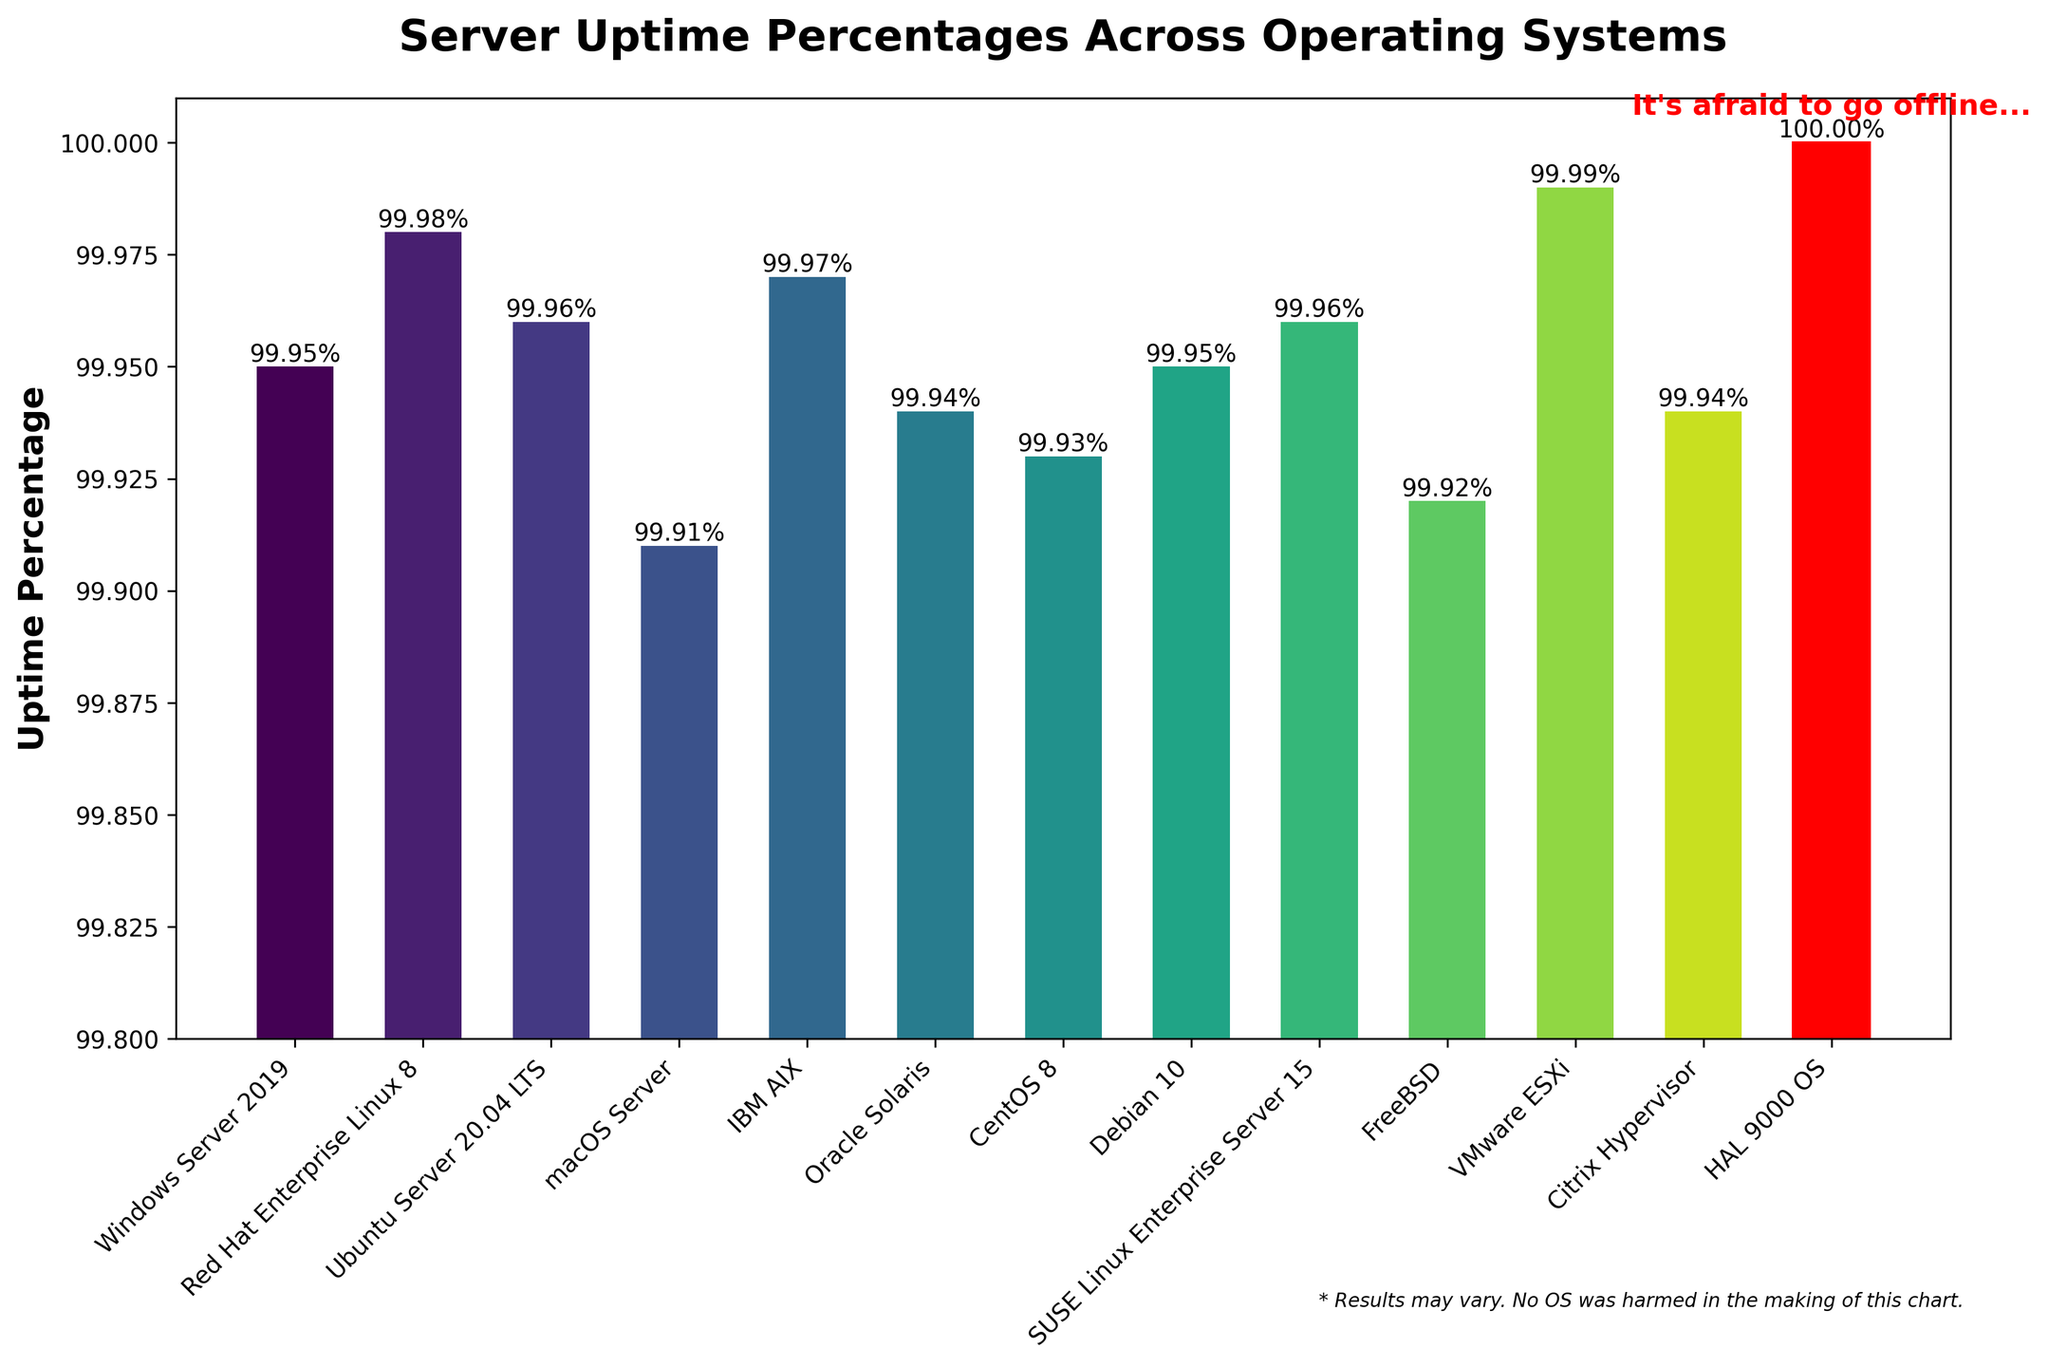Which Operating System has the highest uptime percentage? HAL 9000 OS has the highest uptime percentage since its bar reaches 100% and is highlighted in red.
Answer: HAL 9000 OS Which two operating systems have equal uptime percentages? By examining the bar heights and the values on top of the bars, Windows Server 2019 and Debian 10 both show 99.95% uptime.
Answer: Windows Server 2019, Debian 10 How does macOS Server compare to FreeBSD in terms of uptime? macOS Server has a slightly higher uptime than FreeBSD. From the bar chart, macOS Server shows 99.91% uptime while FreeBSD shows 99.92%.
Answer: macOS Server is lower What is the difference in uptime percentage between VMware ESXi and Oracle Solaris? VMware ESXi has 99.99% uptime, and Oracle Solaris has 99.94% uptime. The difference is 99.99% - 99.94% = 0.05%.
Answer: 0.05% Which bar is highlighted in red, and why? The bar for HAL 9000 OS is highlighted in red with an annotation above stating, "It's afraid to go offline..." to humorously emphasize its perfect 100% uptime.
Answer: HAL 9000 OS What is the average uptime percentage of the listed Linux distributions (Red Hat, Ubuntu, CentOS, Debian, SUSE)? The uptime percentages are Red Hat (99.98%), Ubuntu (99.96%), CentOS (99.93%), Debian (99.95%), and SUSE (99.96%). The average is (99.98 + 99.96 + 99.93 + 99.95 + 99.96) / 5 = 99.96%.
Answer: 99.96% What is the uptime percentage range (difference between highest and lowest uptimes) of all the operating systems excluding HAL 9000 OS? Excluding HAL 9000 OS, the highest uptime is 99.99% (VMware ESXi) and the lowest is 99.91% (macOS Server). The range is 99.99% - 99.91% = 0.08%.
Answer: 0.08% How many operating systems have uptime percentages above 99.95%? By counting the bars above the 99.95% threshold, there are five operating systems: Red Hat Enterprise Linux 8, Ubuntu Server 20.04 LTS, IBM AIX, SUSE Linux Enterprise Server 15, and VMware ESXi.
Answer: 5 What is the combined uptime percentage of the top three operating systems? The top three operating systems are HAL 9000 OS (100%), VMware ESXi (99.99%), and Red Hat Enterprise Linux 8 (99.98%). The combined uptime is 100 + 99.99 + 99.98 = 299.97%.
Answer: 299.97% 